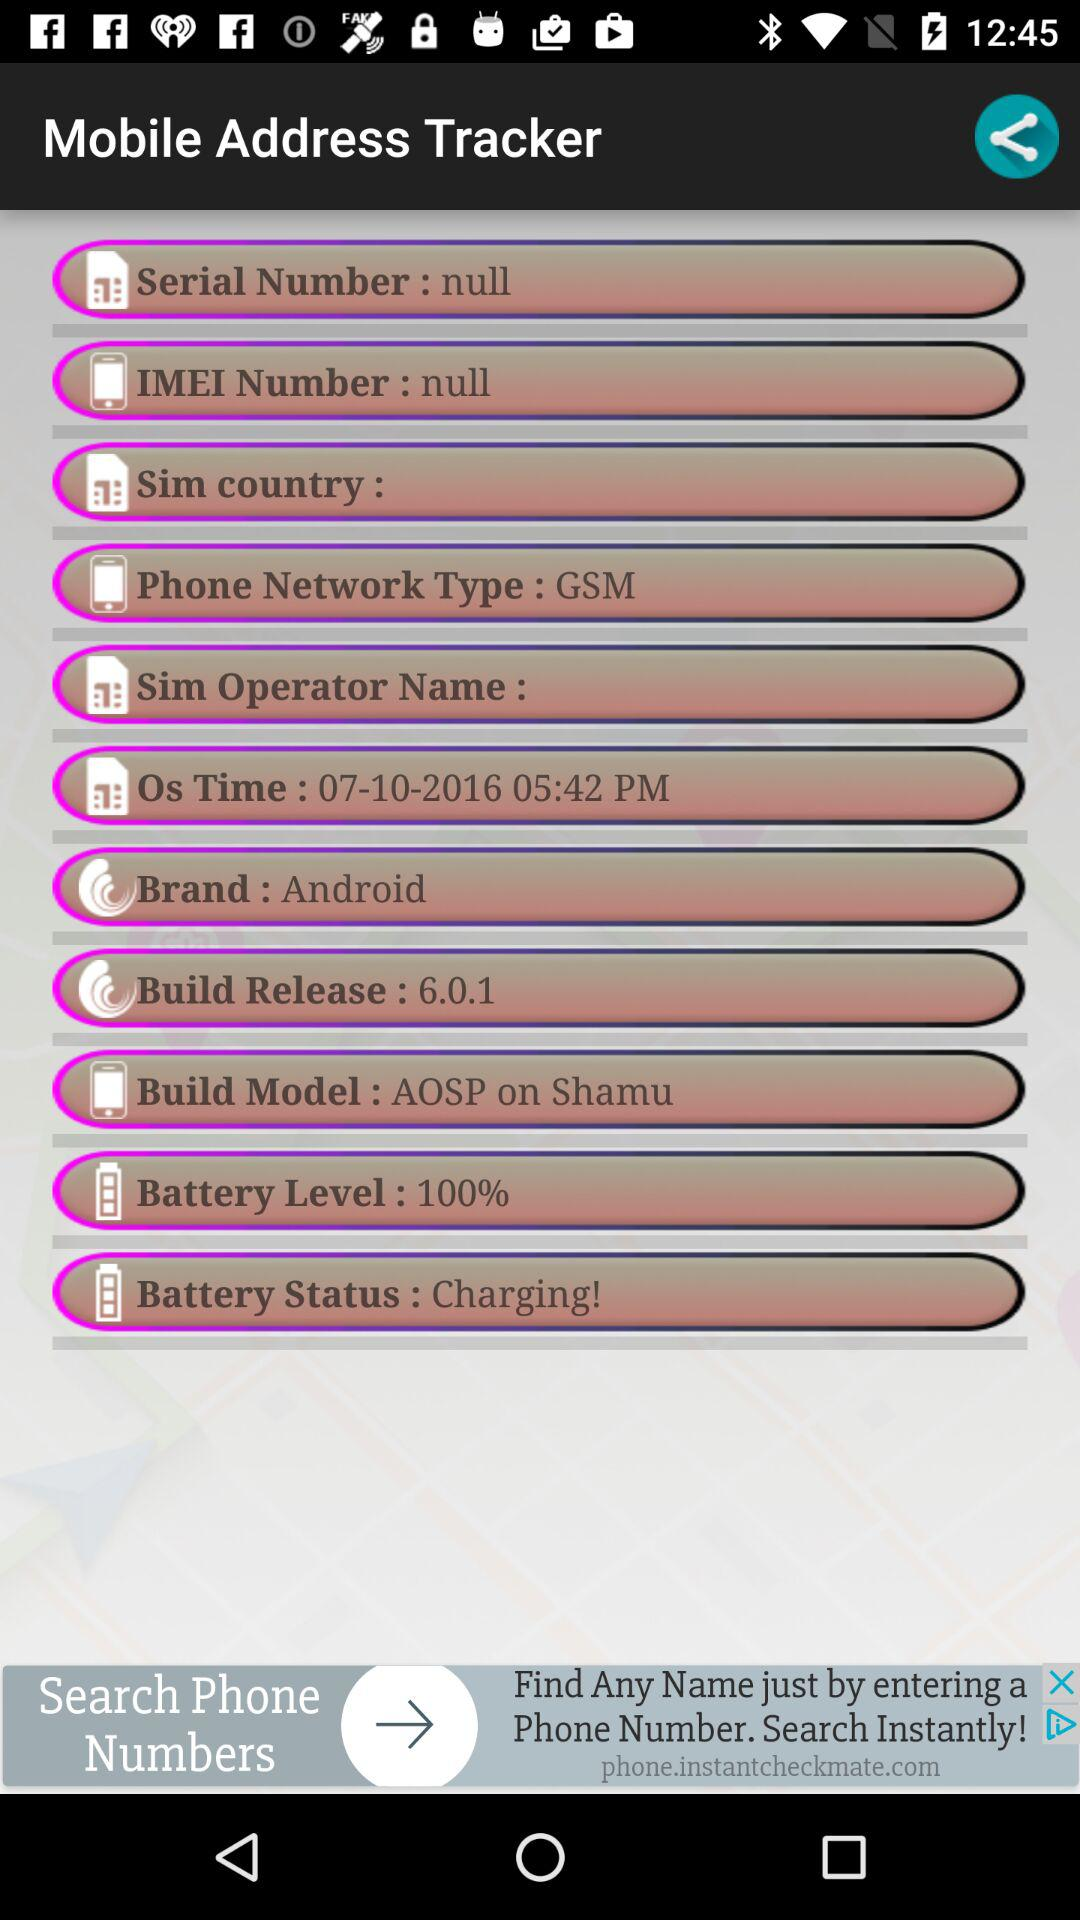What is the IMEI number? The IMEI number is null. 